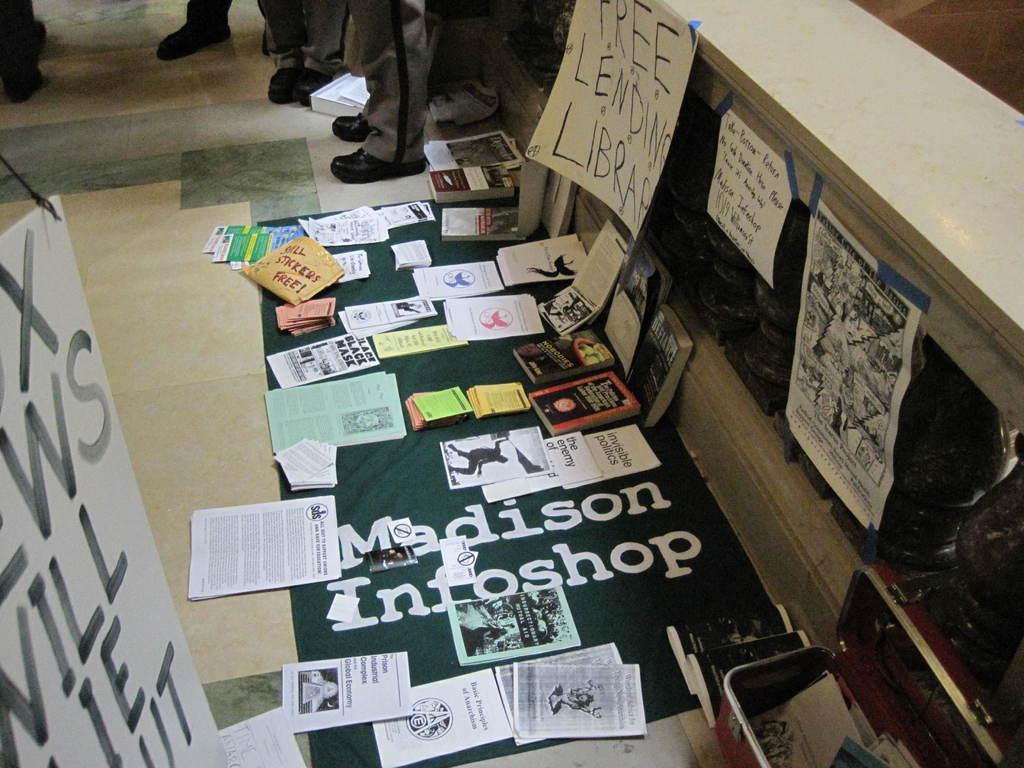How would you summarize this image in a sentence or two? In this picture we can see papers,books,posters and in the background we can see persons legs. 